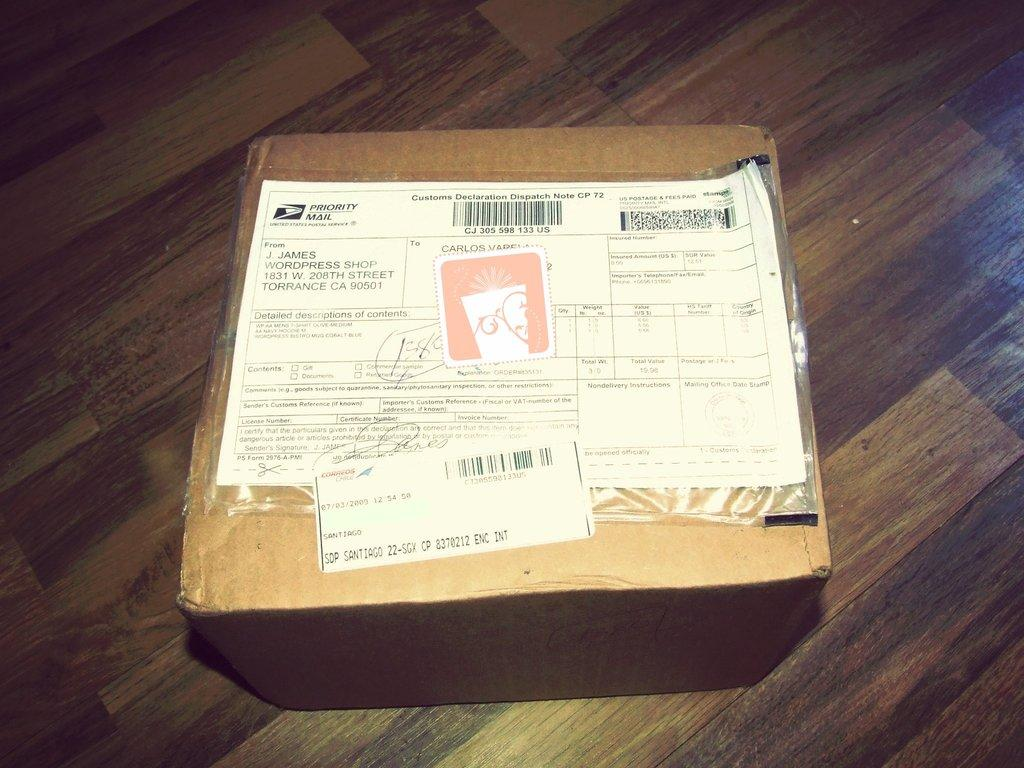Provide a one-sentence caption for the provided image. a paper with Priority Mail written on it. 